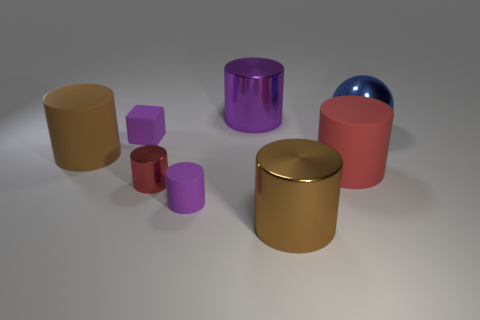The small metallic cylinder has what color?
Provide a succinct answer. Red. Is there a small cyan cylinder made of the same material as the blue ball?
Your answer should be compact. No. Is there a brown metallic object behind the tiny red cylinder that is to the right of the purple matte object that is behind the big red rubber cylinder?
Your answer should be compact. No. Are there any big blue spheres left of the blue ball?
Your response must be concise. No. Is there a rubber cube that has the same color as the small shiny object?
Offer a terse response. No. How many tiny objects are brown metallic cylinders or brown metal balls?
Your response must be concise. 0. Are the small purple cylinder on the right side of the red metal cylinder and the big blue object made of the same material?
Provide a succinct answer. No. There is a brown thing that is in front of the red cylinder to the left of the object behind the big blue thing; what is its shape?
Provide a short and direct response. Cylinder. How many purple objects are either tiny objects or big matte cylinders?
Your response must be concise. 2. Is the number of big metallic cylinders behind the large metal sphere the same as the number of large purple cylinders on the left side of the tiny red metal cylinder?
Keep it short and to the point. No. 